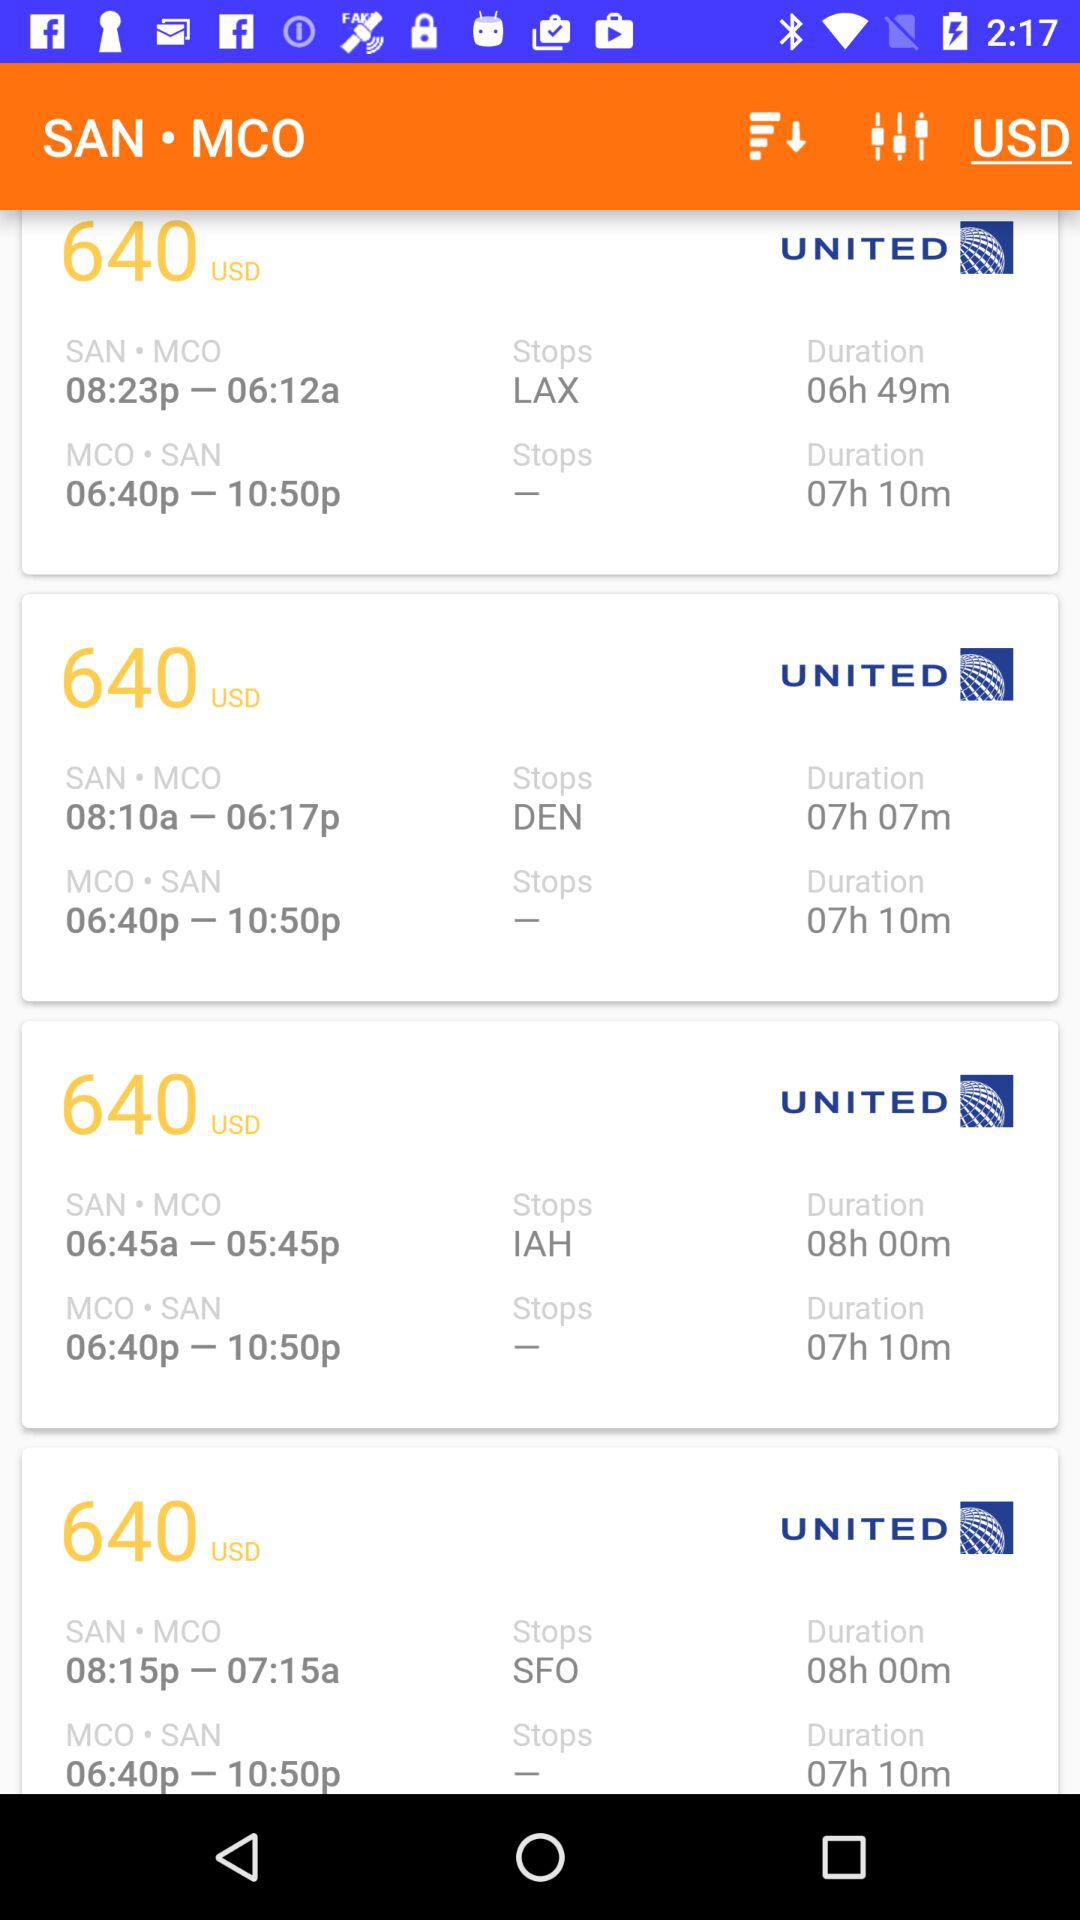What is the price? The price is 640 USD. 